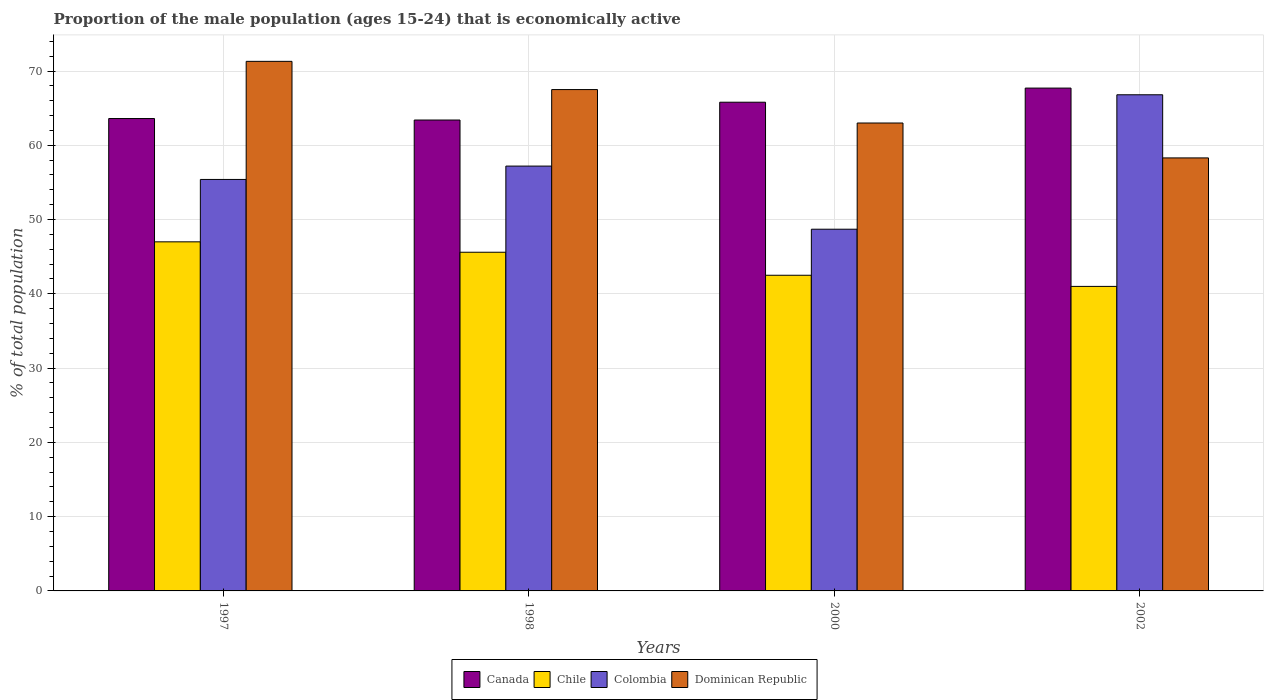How many different coloured bars are there?
Keep it short and to the point. 4. How many groups of bars are there?
Offer a very short reply. 4. Are the number of bars per tick equal to the number of legend labels?
Ensure brevity in your answer.  Yes. What is the label of the 2nd group of bars from the left?
Make the answer very short. 1998. What is the proportion of the male population that is economically active in Colombia in 1998?
Provide a short and direct response. 57.2. Across all years, what is the minimum proportion of the male population that is economically active in Chile?
Your response must be concise. 41. In which year was the proportion of the male population that is economically active in Colombia maximum?
Your answer should be compact. 2002. What is the total proportion of the male population that is economically active in Chile in the graph?
Your response must be concise. 176.1. What is the difference between the proportion of the male population that is economically active in Canada in 1997 and that in 1998?
Your answer should be compact. 0.2. What is the difference between the proportion of the male population that is economically active in Dominican Republic in 2000 and the proportion of the male population that is economically active in Colombia in 1997?
Provide a short and direct response. 7.6. What is the average proportion of the male population that is economically active in Canada per year?
Offer a terse response. 65.12. In the year 2000, what is the difference between the proportion of the male population that is economically active in Canada and proportion of the male population that is economically active in Chile?
Make the answer very short. 23.3. In how many years, is the proportion of the male population that is economically active in Chile greater than 68 %?
Make the answer very short. 0. What is the ratio of the proportion of the male population that is economically active in Canada in 1997 to that in 2002?
Your response must be concise. 0.94. Is the proportion of the male population that is economically active in Colombia in 1997 less than that in 1998?
Provide a succinct answer. Yes. What is the difference between the highest and the second highest proportion of the male population that is economically active in Chile?
Offer a very short reply. 1.4. What is the difference between the highest and the lowest proportion of the male population that is economically active in Canada?
Keep it short and to the point. 4.3. In how many years, is the proportion of the male population that is economically active in Colombia greater than the average proportion of the male population that is economically active in Colombia taken over all years?
Provide a short and direct response. 2. Is the sum of the proportion of the male population that is economically active in Chile in 1998 and 2002 greater than the maximum proportion of the male population that is economically active in Colombia across all years?
Provide a succinct answer. Yes. Is it the case that in every year, the sum of the proportion of the male population that is economically active in Dominican Republic and proportion of the male population that is economically active in Colombia is greater than the sum of proportion of the male population that is economically active in Chile and proportion of the male population that is economically active in Canada?
Offer a very short reply. Yes. What does the 4th bar from the left in 2002 represents?
Make the answer very short. Dominican Republic. What does the 3rd bar from the right in 1998 represents?
Give a very brief answer. Chile. What is the difference between two consecutive major ticks on the Y-axis?
Offer a very short reply. 10. Are the values on the major ticks of Y-axis written in scientific E-notation?
Give a very brief answer. No. Does the graph contain any zero values?
Your response must be concise. No. Does the graph contain grids?
Ensure brevity in your answer.  Yes. What is the title of the graph?
Your answer should be compact. Proportion of the male population (ages 15-24) that is economically active. What is the label or title of the X-axis?
Provide a succinct answer. Years. What is the label or title of the Y-axis?
Your answer should be very brief. % of total population. What is the % of total population in Canada in 1997?
Give a very brief answer. 63.6. What is the % of total population in Chile in 1997?
Your response must be concise. 47. What is the % of total population of Colombia in 1997?
Keep it short and to the point. 55.4. What is the % of total population in Dominican Republic in 1997?
Provide a succinct answer. 71.3. What is the % of total population in Canada in 1998?
Your answer should be compact. 63.4. What is the % of total population of Chile in 1998?
Give a very brief answer. 45.6. What is the % of total population of Colombia in 1998?
Provide a short and direct response. 57.2. What is the % of total population of Dominican Republic in 1998?
Give a very brief answer. 67.5. What is the % of total population in Canada in 2000?
Give a very brief answer. 65.8. What is the % of total population of Chile in 2000?
Make the answer very short. 42.5. What is the % of total population in Colombia in 2000?
Give a very brief answer. 48.7. What is the % of total population in Canada in 2002?
Give a very brief answer. 67.7. What is the % of total population in Chile in 2002?
Ensure brevity in your answer.  41. What is the % of total population of Colombia in 2002?
Offer a very short reply. 66.8. What is the % of total population of Dominican Republic in 2002?
Ensure brevity in your answer.  58.3. Across all years, what is the maximum % of total population of Canada?
Keep it short and to the point. 67.7. Across all years, what is the maximum % of total population in Chile?
Keep it short and to the point. 47. Across all years, what is the maximum % of total population of Colombia?
Provide a short and direct response. 66.8. Across all years, what is the maximum % of total population in Dominican Republic?
Offer a very short reply. 71.3. Across all years, what is the minimum % of total population of Canada?
Your answer should be compact. 63.4. Across all years, what is the minimum % of total population of Chile?
Offer a terse response. 41. Across all years, what is the minimum % of total population of Colombia?
Ensure brevity in your answer.  48.7. Across all years, what is the minimum % of total population in Dominican Republic?
Offer a terse response. 58.3. What is the total % of total population of Canada in the graph?
Your answer should be very brief. 260.5. What is the total % of total population in Chile in the graph?
Keep it short and to the point. 176.1. What is the total % of total population in Colombia in the graph?
Ensure brevity in your answer.  228.1. What is the total % of total population of Dominican Republic in the graph?
Make the answer very short. 260.1. What is the difference between the % of total population in Chile in 1997 and that in 1998?
Offer a very short reply. 1.4. What is the difference between the % of total population in Colombia in 1997 and that in 1998?
Your answer should be very brief. -1.8. What is the difference between the % of total population of Dominican Republic in 1997 and that in 1998?
Your response must be concise. 3.8. What is the difference between the % of total population of Canada in 1997 and that in 2000?
Make the answer very short. -2.2. What is the difference between the % of total population of Colombia in 1997 and that in 2000?
Keep it short and to the point. 6.7. What is the difference between the % of total population in Dominican Republic in 1997 and that in 2002?
Offer a very short reply. 13. What is the difference between the % of total population in Colombia in 1998 and that in 2000?
Make the answer very short. 8.5. What is the difference between the % of total population of Dominican Republic in 1998 and that in 2002?
Keep it short and to the point. 9.2. What is the difference between the % of total population of Canada in 2000 and that in 2002?
Your response must be concise. -1.9. What is the difference between the % of total population of Chile in 2000 and that in 2002?
Keep it short and to the point. 1.5. What is the difference between the % of total population of Colombia in 2000 and that in 2002?
Your answer should be very brief. -18.1. What is the difference between the % of total population in Canada in 1997 and the % of total population in Chile in 1998?
Your answer should be compact. 18. What is the difference between the % of total population in Chile in 1997 and the % of total population in Dominican Republic in 1998?
Your response must be concise. -20.5. What is the difference between the % of total population in Canada in 1997 and the % of total population in Chile in 2000?
Keep it short and to the point. 21.1. What is the difference between the % of total population in Canada in 1997 and the % of total population in Colombia in 2000?
Give a very brief answer. 14.9. What is the difference between the % of total population of Canada in 1997 and the % of total population of Dominican Republic in 2000?
Ensure brevity in your answer.  0.6. What is the difference between the % of total population of Chile in 1997 and the % of total population of Colombia in 2000?
Ensure brevity in your answer.  -1.7. What is the difference between the % of total population of Canada in 1997 and the % of total population of Chile in 2002?
Give a very brief answer. 22.6. What is the difference between the % of total population in Canada in 1997 and the % of total population in Colombia in 2002?
Ensure brevity in your answer.  -3.2. What is the difference between the % of total population of Chile in 1997 and the % of total population of Colombia in 2002?
Provide a succinct answer. -19.8. What is the difference between the % of total population in Chile in 1997 and the % of total population in Dominican Republic in 2002?
Your answer should be compact. -11.3. What is the difference between the % of total population of Canada in 1998 and the % of total population of Chile in 2000?
Give a very brief answer. 20.9. What is the difference between the % of total population in Canada in 1998 and the % of total population in Colombia in 2000?
Your response must be concise. 14.7. What is the difference between the % of total population in Chile in 1998 and the % of total population in Colombia in 2000?
Your answer should be very brief. -3.1. What is the difference between the % of total population of Chile in 1998 and the % of total population of Dominican Republic in 2000?
Offer a very short reply. -17.4. What is the difference between the % of total population in Canada in 1998 and the % of total population in Chile in 2002?
Offer a terse response. 22.4. What is the difference between the % of total population of Canada in 1998 and the % of total population of Colombia in 2002?
Keep it short and to the point. -3.4. What is the difference between the % of total population in Chile in 1998 and the % of total population in Colombia in 2002?
Give a very brief answer. -21.2. What is the difference between the % of total population in Chile in 1998 and the % of total population in Dominican Republic in 2002?
Ensure brevity in your answer.  -12.7. What is the difference between the % of total population in Canada in 2000 and the % of total population in Chile in 2002?
Your answer should be very brief. 24.8. What is the difference between the % of total population of Canada in 2000 and the % of total population of Dominican Republic in 2002?
Your answer should be very brief. 7.5. What is the difference between the % of total population in Chile in 2000 and the % of total population in Colombia in 2002?
Your answer should be compact. -24.3. What is the difference between the % of total population in Chile in 2000 and the % of total population in Dominican Republic in 2002?
Provide a short and direct response. -15.8. What is the average % of total population of Canada per year?
Your answer should be compact. 65.12. What is the average % of total population in Chile per year?
Provide a short and direct response. 44.02. What is the average % of total population of Colombia per year?
Provide a succinct answer. 57.02. What is the average % of total population in Dominican Republic per year?
Your answer should be compact. 65.03. In the year 1997, what is the difference between the % of total population in Canada and % of total population in Chile?
Keep it short and to the point. 16.6. In the year 1997, what is the difference between the % of total population in Canada and % of total population in Colombia?
Provide a short and direct response. 8.2. In the year 1997, what is the difference between the % of total population in Chile and % of total population in Colombia?
Your answer should be compact. -8.4. In the year 1997, what is the difference between the % of total population in Chile and % of total population in Dominican Republic?
Provide a short and direct response. -24.3. In the year 1997, what is the difference between the % of total population in Colombia and % of total population in Dominican Republic?
Provide a short and direct response. -15.9. In the year 1998, what is the difference between the % of total population of Canada and % of total population of Chile?
Your answer should be compact. 17.8. In the year 1998, what is the difference between the % of total population of Chile and % of total population of Colombia?
Offer a terse response. -11.6. In the year 1998, what is the difference between the % of total population of Chile and % of total population of Dominican Republic?
Your response must be concise. -21.9. In the year 2000, what is the difference between the % of total population of Canada and % of total population of Chile?
Give a very brief answer. 23.3. In the year 2000, what is the difference between the % of total population of Canada and % of total population of Dominican Republic?
Provide a short and direct response. 2.8. In the year 2000, what is the difference between the % of total population of Chile and % of total population of Colombia?
Your response must be concise. -6.2. In the year 2000, what is the difference between the % of total population in Chile and % of total population in Dominican Republic?
Your answer should be very brief. -20.5. In the year 2000, what is the difference between the % of total population of Colombia and % of total population of Dominican Republic?
Ensure brevity in your answer.  -14.3. In the year 2002, what is the difference between the % of total population of Canada and % of total population of Chile?
Provide a succinct answer. 26.7. In the year 2002, what is the difference between the % of total population in Canada and % of total population in Colombia?
Offer a very short reply. 0.9. In the year 2002, what is the difference between the % of total population in Canada and % of total population in Dominican Republic?
Your response must be concise. 9.4. In the year 2002, what is the difference between the % of total population in Chile and % of total population in Colombia?
Provide a short and direct response. -25.8. In the year 2002, what is the difference between the % of total population of Chile and % of total population of Dominican Republic?
Offer a very short reply. -17.3. In the year 2002, what is the difference between the % of total population of Colombia and % of total population of Dominican Republic?
Offer a terse response. 8.5. What is the ratio of the % of total population in Canada in 1997 to that in 1998?
Give a very brief answer. 1. What is the ratio of the % of total population in Chile in 1997 to that in 1998?
Make the answer very short. 1.03. What is the ratio of the % of total population of Colombia in 1997 to that in 1998?
Offer a terse response. 0.97. What is the ratio of the % of total population of Dominican Republic in 1997 to that in 1998?
Your response must be concise. 1.06. What is the ratio of the % of total population of Canada in 1997 to that in 2000?
Offer a terse response. 0.97. What is the ratio of the % of total population in Chile in 1997 to that in 2000?
Give a very brief answer. 1.11. What is the ratio of the % of total population of Colombia in 1997 to that in 2000?
Make the answer very short. 1.14. What is the ratio of the % of total population in Dominican Republic in 1997 to that in 2000?
Offer a very short reply. 1.13. What is the ratio of the % of total population of Canada in 1997 to that in 2002?
Offer a very short reply. 0.94. What is the ratio of the % of total population of Chile in 1997 to that in 2002?
Your answer should be compact. 1.15. What is the ratio of the % of total population of Colombia in 1997 to that in 2002?
Offer a terse response. 0.83. What is the ratio of the % of total population of Dominican Republic in 1997 to that in 2002?
Give a very brief answer. 1.22. What is the ratio of the % of total population of Canada in 1998 to that in 2000?
Ensure brevity in your answer.  0.96. What is the ratio of the % of total population in Chile in 1998 to that in 2000?
Make the answer very short. 1.07. What is the ratio of the % of total population of Colombia in 1998 to that in 2000?
Ensure brevity in your answer.  1.17. What is the ratio of the % of total population in Dominican Republic in 1998 to that in 2000?
Offer a very short reply. 1.07. What is the ratio of the % of total population of Canada in 1998 to that in 2002?
Your answer should be very brief. 0.94. What is the ratio of the % of total population of Chile in 1998 to that in 2002?
Your response must be concise. 1.11. What is the ratio of the % of total population of Colombia in 1998 to that in 2002?
Your response must be concise. 0.86. What is the ratio of the % of total population of Dominican Republic in 1998 to that in 2002?
Your response must be concise. 1.16. What is the ratio of the % of total population in Canada in 2000 to that in 2002?
Your answer should be very brief. 0.97. What is the ratio of the % of total population of Chile in 2000 to that in 2002?
Make the answer very short. 1.04. What is the ratio of the % of total population of Colombia in 2000 to that in 2002?
Your answer should be very brief. 0.73. What is the ratio of the % of total population of Dominican Republic in 2000 to that in 2002?
Ensure brevity in your answer.  1.08. What is the difference between the highest and the second highest % of total population in Colombia?
Make the answer very short. 9.6. What is the difference between the highest and the second highest % of total population of Dominican Republic?
Make the answer very short. 3.8. What is the difference between the highest and the lowest % of total population in Canada?
Keep it short and to the point. 4.3. 